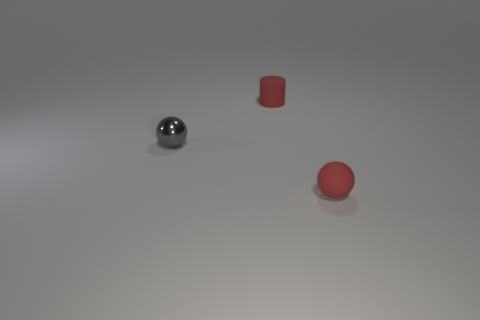Add 2 small green metal objects. How many objects exist? 5 Subtract all cylinders. How many objects are left? 2 Subtract all small gray metal spheres. Subtract all cyan rubber cylinders. How many objects are left? 2 Add 2 small matte cylinders. How many small matte cylinders are left? 3 Add 2 tiny green metallic cylinders. How many tiny green metallic cylinders exist? 2 Subtract 0 green balls. How many objects are left? 3 